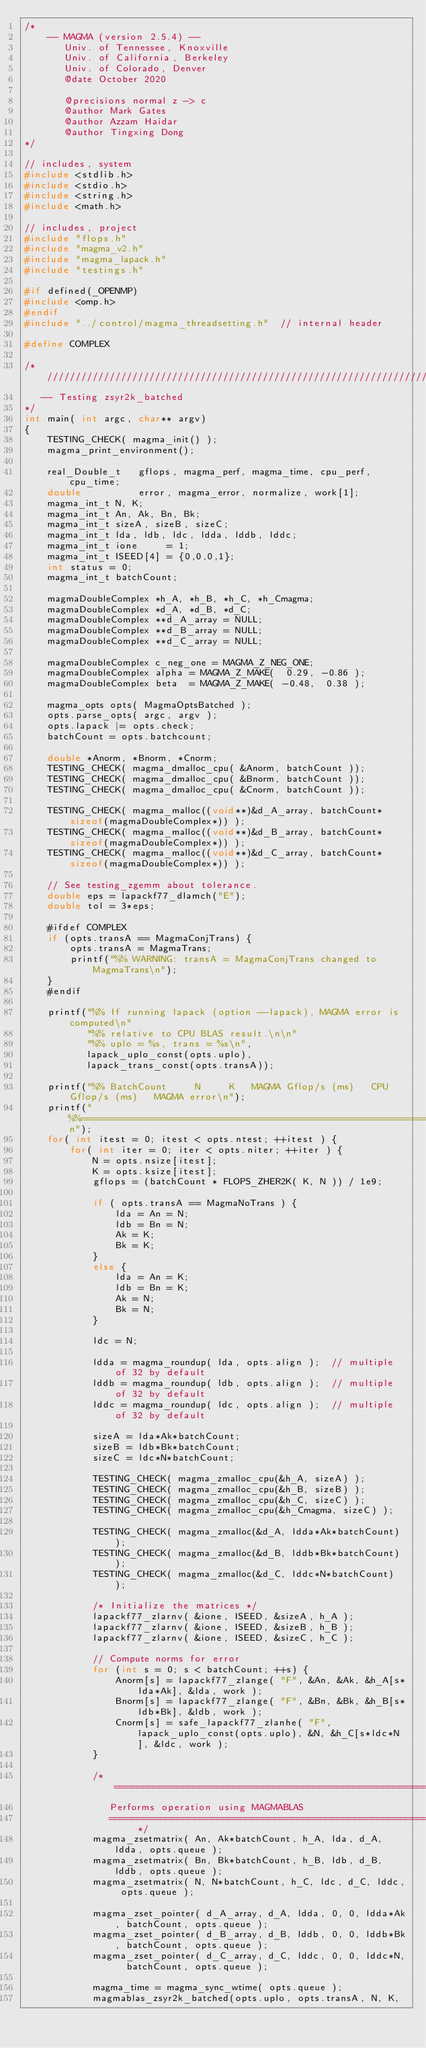Convert code to text. <code><loc_0><loc_0><loc_500><loc_500><_C++_>/*
    -- MAGMA (version 2.5.4) --
       Univ. of Tennessee, Knoxville
       Univ. of California, Berkeley
       Univ. of Colorado, Denver
       @date October 2020

       @precisions normal z -> c
       @author Mark Gates
       @author Azzam Haidar
       @author Tingxing Dong
*/

// includes, system
#include <stdlib.h>
#include <stdio.h>
#include <string.h>
#include <math.h>

// includes, project
#include "flops.h"
#include "magma_v2.h"
#include "magma_lapack.h"
#include "testings.h"

#if defined(_OPENMP)
#include <omp.h>
#endif
#include "../control/magma_threadsetting.h"  // internal header

#define COMPLEX

/* ////////////////////////////////////////////////////////////////////////////
   -- Testing zsyr2k_batched
*/
int main( int argc, char** argv)
{
    TESTING_CHECK( magma_init() );
    magma_print_environment();

    real_Double_t   gflops, magma_perf, magma_time, cpu_perf, cpu_time;
    double          error, magma_error, normalize, work[1];
    magma_int_t N, K;
    magma_int_t An, Ak, Bn, Bk;
    magma_int_t sizeA, sizeB, sizeC;
    magma_int_t lda, ldb, ldc, ldda, lddb, lddc;
    magma_int_t ione     = 1;
    magma_int_t ISEED[4] = {0,0,0,1};
    int status = 0;
    magma_int_t batchCount;

    magmaDoubleComplex *h_A, *h_B, *h_C, *h_Cmagma;
    magmaDoubleComplex *d_A, *d_B, *d_C;
    magmaDoubleComplex **d_A_array = NULL;
    magmaDoubleComplex **d_B_array = NULL;
    magmaDoubleComplex **d_C_array = NULL;

    magmaDoubleComplex c_neg_one = MAGMA_Z_NEG_ONE;
    magmaDoubleComplex alpha = MAGMA_Z_MAKE(  0.29, -0.86 );
    magmaDoubleComplex beta  = MAGMA_Z_MAKE( -0.48,  0.38 );
    
    magma_opts opts( MagmaOptsBatched );
    opts.parse_opts( argc, argv );
    opts.lapack |= opts.check;
    batchCount = opts.batchcount;
    
    double *Anorm, *Bnorm, *Cnorm;
    TESTING_CHECK( magma_dmalloc_cpu( &Anorm, batchCount ));
    TESTING_CHECK( magma_dmalloc_cpu( &Bnorm, batchCount ));
    TESTING_CHECK( magma_dmalloc_cpu( &Cnorm, batchCount ));
    
    TESTING_CHECK( magma_malloc((void**)&d_A_array, batchCount*sizeof(magmaDoubleComplex*)) );
    TESTING_CHECK( magma_malloc((void**)&d_B_array, batchCount*sizeof(magmaDoubleComplex*)) );
    TESTING_CHECK( magma_malloc((void**)&d_C_array, batchCount*sizeof(magmaDoubleComplex*)) );
    
    // See testing_zgemm about tolerance.
    double eps = lapackf77_dlamch("E");
    double tol = 3*eps;
    
    #ifdef COMPLEX
    if (opts.transA == MagmaConjTrans) {
        opts.transA = MagmaTrans;
        printf("%% WARNING: transA = MagmaConjTrans changed to MagmaTrans\n");
    }
    #endif
    
    printf("%% If running lapack (option --lapack), MAGMA error is computed\n"
           "%% relative to CPU BLAS result.\n\n"
           "%% uplo = %s, trans = %s\n",
           lapack_uplo_const(opts.uplo),
           lapack_trans_const(opts.transA));
    
    printf("%% BatchCount     N     K   MAGMA Gflop/s (ms)   CPU Gflop/s (ms)   MAGMA error\n");
    printf("%%=============================================================================\n");
    for( int itest = 0; itest < opts.ntest; ++itest ) {
        for( int iter = 0; iter < opts.niter; ++iter ) {
            N = opts.nsize[itest];
            K = opts.ksize[itest];
            gflops = (batchCount * FLOPS_ZHER2K( K, N )) / 1e9;

            if ( opts.transA == MagmaNoTrans ) {
                lda = An = N;
                ldb = Bn = N;
                Ak = K;
                Bk = K;
            }
            else {
                lda = An = K;
                ldb = Bn = K;
                Ak = N;
                Bk = N;
            }
            
            ldc = N;
            
            ldda = magma_roundup( lda, opts.align );  // multiple of 32 by default
            lddb = magma_roundup( ldb, opts.align );  // multiple of 32 by default
            lddc = magma_roundup( ldc, opts.align );  // multiple of 32 by default

            sizeA = lda*Ak*batchCount;
            sizeB = ldb*Bk*batchCount;
            sizeC = ldc*N*batchCount;
            
            TESTING_CHECK( magma_zmalloc_cpu(&h_A, sizeA) );
            TESTING_CHECK( magma_zmalloc_cpu(&h_B, sizeB) );
            TESTING_CHECK( magma_zmalloc_cpu(&h_C, sizeC) );
            TESTING_CHECK( magma_zmalloc_cpu(&h_Cmagma, sizeC) );

            TESTING_CHECK( magma_zmalloc(&d_A, ldda*Ak*batchCount) );
            TESTING_CHECK( magma_zmalloc(&d_B, lddb*Bk*batchCount) );
            TESTING_CHECK( magma_zmalloc(&d_C, lddc*N*batchCount)  );

            /* Initialize the matrices */
            lapackf77_zlarnv( &ione, ISEED, &sizeA, h_A );
            lapackf77_zlarnv( &ione, ISEED, &sizeB, h_B );
            lapackf77_zlarnv( &ione, ISEED, &sizeC, h_C );
            
            // Compute norms for error
            for (int s = 0; s < batchCount; ++s) {
                Anorm[s] = lapackf77_zlange( "F", &An, &Ak, &h_A[s*lda*Ak], &lda, work );
                Bnorm[s] = lapackf77_zlange( "F", &Bn, &Bk, &h_B[s*ldb*Bk], &ldb, work );
                Cnorm[s] = safe_lapackf77_zlanhe( "F", lapack_uplo_const(opts.uplo), &N, &h_C[s*ldc*N], &ldc, work );
            }

            /* =====================================================================
               Performs operation using MAGMABLAS
               =================================================================== */
            magma_zsetmatrix( An, Ak*batchCount, h_A, lda, d_A, ldda, opts.queue );
            magma_zsetmatrix( Bn, Bk*batchCount, h_B, ldb, d_B, lddb, opts.queue );
            magma_zsetmatrix( N, N*batchCount, h_C, ldc, d_C, lddc, opts.queue );
            
            magma_zset_pointer( d_A_array, d_A, ldda, 0, 0, ldda*Ak, batchCount, opts.queue );
            magma_zset_pointer( d_B_array, d_B, lddb, 0, 0, lddb*Bk, batchCount, opts.queue );
            magma_zset_pointer( d_C_array, d_C, lddc, 0, 0, lddc*N,  batchCount, opts.queue );

            magma_time = magma_sync_wtime( opts.queue );
            magmablas_zsyr2k_batched(opts.uplo, opts.transA, N, K, </code> 